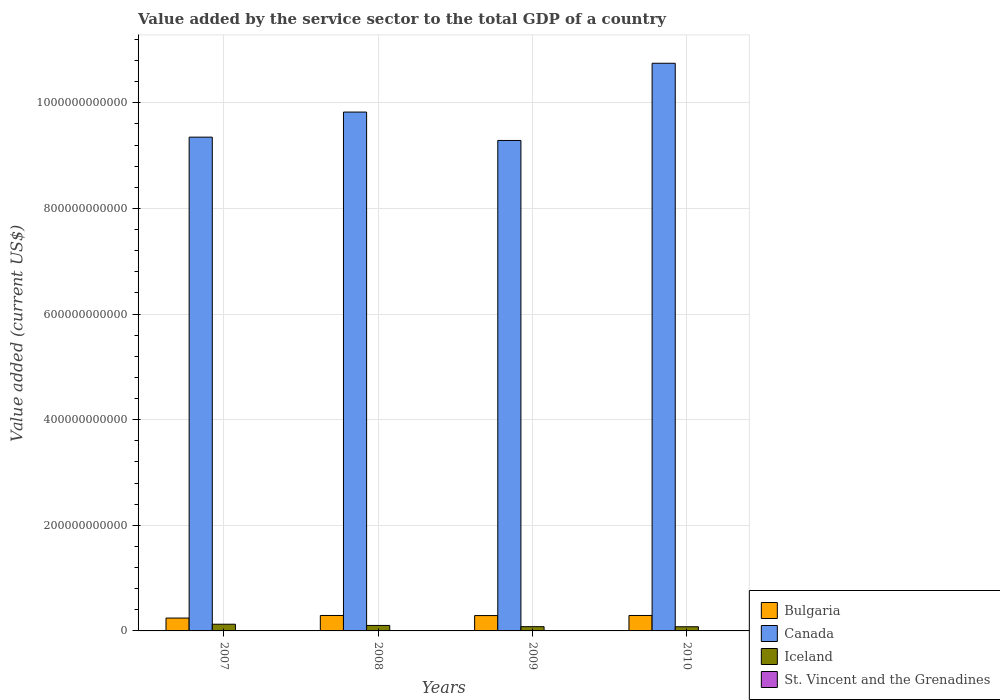How many groups of bars are there?
Offer a terse response. 4. How many bars are there on the 2nd tick from the left?
Ensure brevity in your answer.  4. In how many cases, is the number of bars for a given year not equal to the number of legend labels?
Your response must be concise. 0. What is the value added by the service sector to the total GDP in Canada in 2008?
Your response must be concise. 9.82e+11. Across all years, what is the maximum value added by the service sector to the total GDP in Canada?
Provide a short and direct response. 1.07e+12. Across all years, what is the minimum value added by the service sector to the total GDP in Iceland?
Ensure brevity in your answer.  7.87e+09. In which year was the value added by the service sector to the total GDP in Bulgaria maximum?
Ensure brevity in your answer.  2008. In which year was the value added by the service sector to the total GDP in St. Vincent and the Grenadines minimum?
Provide a succinct answer. 2009. What is the total value added by the service sector to the total GDP in Iceland in the graph?
Provide a succinct answer. 3.89e+1. What is the difference between the value added by the service sector to the total GDP in St. Vincent and the Grenadines in 2009 and that in 2010?
Your answer should be very brief. -6.89e+06. What is the difference between the value added by the service sector to the total GDP in St. Vincent and the Grenadines in 2010 and the value added by the service sector to the total GDP in Iceland in 2009?
Offer a terse response. -7.60e+09. What is the average value added by the service sector to the total GDP in St. Vincent and the Grenadines per year?
Provide a short and direct response. 4.24e+08. In the year 2009, what is the difference between the value added by the service sector to the total GDP in Bulgaria and value added by the service sector to the total GDP in Canada?
Provide a succinct answer. -9.00e+11. In how many years, is the value added by the service sector to the total GDP in Bulgaria greater than 400000000000 US$?
Ensure brevity in your answer.  0. What is the ratio of the value added by the service sector to the total GDP in Iceland in 2007 to that in 2008?
Your answer should be compact. 1.22. What is the difference between the highest and the second highest value added by the service sector to the total GDP in Bulgaria?
Your answer should be very brief. 1.87e+06. What is the difference between the highest and the lowest value added by the service sector to the total GDP in St. Vincent and the Grenadines?
Ensure brevity in your answer.  1.52e+07. Are all the bars in the graph horizontal?
Your answer should be compact. No. How many years are there in the graph?
Give a very brief answer. 4. What is the difference between two consecutive major ticks on the Y-axis?
Your answer should be compact. 2.00e+11. Are the values on the major ticks of Y-axis written in scientific E-notation?
Your answer should be compact. No. Where does the legend appear in the graph?
Ensure brevity in your answer.  Bottom right. How are the legend labels stacked?
Offer a terse response. Vertical. What is the title of the graph?
Your response must be concise. Value added by the service sector to the total GDP of a country. What is the label or title of the X-axis?
Your answer should be very brief. Years. What is the label or title of the Y-axis?
Provide a short and direct response. Value added (current US$). What is the Value added (current US$) in Bulgaria in 2007?
Keep it short and to the point. 2.44e+1. What is the Value added (current US$) in Canada in 2007?
Provide a short and direct response. 9.35e+11. What is the Value added (current US$) of Iceland in 2007?
Provide a short and direct response. 1.27e+1. What is the Value added (current US$) in St. Vincent and the Grenadines in 2007?
Provide a short and direct response. 4.25e+08. What is the Value added (current US$) of Bulgaria in 2008?
Your answer should be compact. 2.93e+1. What is the Value added (current US$) of Canada in 2008?
Your answer should be very brief. 9.82e+11. What is the Value added (current US$) of Iceland in 2008?
Offer a very short reply. 1.04e+1. What is the Value added (current US$) of St. Vincent and the Grenadines in 2008?
Provide a succinct answer. 4.31e+08. What is the Value added (current US$) in Bulgaria in 2009?
Provide a succinct answer. 2.91e+1. What is the Value added (current US$) in Canada in 2009?
Provide a short and direct response. 9.29e+11. What is the Value added (current US$) in Iceland in 2009?
Give a very brief answer. 8.03e+09. What is the Value added (current US$) of St. Vincent and the Grenadines in 2009?
Offer a terse response. 4.16e+08. What is the Value added (current US$) in Bulgaria in 2010?
Make the answer very short. 2.93e+1. What is the Value added (current US$) in Canada in 2010?
Keep it short and to the point. 1.07e+12. What is the Value added (current US$) of Iceland in 2010?
Make the answer very short. 7.87e+09. What is the Value added (current US$) in St. Vincent and the Grenadines in 2010?
Ensure brevity in your answer.  4.23e+08. Across all years, what is the maximum Value added (current US$) in Bulgaria?
Your answer should be very brief. 2.93e+1. Across all years, what is the maximum Value added (current US$) of Canada?
Keep it short and to the point. 1.07e+12. Across all years, what is the maximum Value added (current US$) of Iceland?
Make the answer very short. 1.27e+1. Across all years, what is the maximum Value added (current US$) of St. Vincent and the Grenadines?
Your answer should be very brief. 4.31e+08. Across all years, what is the minimum Value added (current US$) of Bulgaria?
Offer a terse response. 2.44e+1. Across all years, what is the minimum Value added (current US$) of Canada?
Your answer should be very brief. 9.29e+11. Across all years, what is the minimum Value added (current US$) of Iceland?
Provide a succinct answer. 7.87e+09. Across all years, what is the minimum Value added (current US$) in St. Vincent and the Grenadines?
Your answer should be compact. 4.16e+08. What is the total Value added (current US$) of Bulgaria in the graph?
Ensure brevity in your answer.  1.12e+11. What is the total Value added (current US$) in Canada in the graph?
Your response must be concise. 3.92e+12. What is the total Value added (current US$) of Iceland in the graph?
Give a very brief answer. 3.89e+1. What is the total Value added (current US$) in St. Vincent and the Grenadines in the graph?
Your answer should be compact. 1.70e+09. What is the difference between the Value added (current US$) of Bulgaria in 2007 and that in 2008?
Your response must be concise. -4.90e+09. What is the difference between the Value added (current US$) in Canada in 2007 and that in 2008?
Provide a short and direct response. -4.75e+1. What is the difference between the Value added (current US$) of Iceland in 2007 and that in 2008?
Offer a very short reply. 2.29e+09. What is the difference between the Value added (current US$) in St. Vincent and the Grenadines in 2007 and that in 2008?
Provide a short and direct response. -5.72e+06. What is the difference between the Value added (current US$) of Bulgaria in 2007 and that in 2009?
Provide a short and direct response. -4.69e+09. What is the difference between the Value added (current US$) of Canada in 2007 and that in 2009?
Your response must be concise. 6.28e+09. What is the difference between the Value added (current US$) of Iceland in 2007 and that in 2009?
Offer a very short reply. 4.64e+09. What is the difference between the Value added (current US$) in St. Vincent and the Grenadines in 2007 and that in 2009?
Your answer should be compact. 9.51e+06. What is the difference between the Value added (current US$) in Bulgaria in 2007 and that in 2010?
Offer a very short reply. -4.89e+09. What is the difference between the Value added (current US$) in Canada in 2007 and that in 2010?
Make the answer very short. -1.40e+11. What is the difference between the Value added (current US$) in Iceland in 2007 and that in 2010?
Keep it short and to the point. 4.79e+09. What is the difference between the Value added (current US$) in St. Vincent and the Grenadines in 2007 and that in 2010?
Offer a terse response. 2.62e+06. What is the difference between the Value added (current US$) of Bulgaria in 2008 and that in 2009?
Your answer should be very brief. 2.04e+08. What is the difference between the Value added (current US$) of Canada in 2008 and that in 2009?
Provide a succinct answer. 5.38e+1. What is the difference between the Value added (current US$) of Iceland in 2008 and that in 2009?
Give a very brief answer. 2.34e+09. What is the difference between the Value added (current US$) in St. Vincent and the Grenadines in 2008 and that in 2009?
Offer a terse response. 1.52e+07. What is the difference between the Value added (current US$) in Bulgaria in 2008 and that in 2010?
Offer a terse response. 1.87e+06. What is the difference between the Value added (current US$) in Canada in 2008 and that in 2010?
Your answer should be very brief. -9.24e+1. What is the difference between the Value added (current US$) of Iceland in 2008 and that in 2010?
Ensure brevity in your answer.  2.50e+09. What is the difference between the Value added (current US$) in St. Vincent and the Grenadines in 2008 and that in 2010?
Offer a terse response. 8.34e+06. What is the difference between the Value added (current US$) in Bulgaria in 2009 and that in 2010?
Offer a terse response. -2.02e+08. What is the difference between the Value added (current US$) in Canada in 2009 and that in 2010?
Keep it short and to the point. -1.46e+11. What is the difference between the Value added (current US$) in Iceland in 2009 and that in 2010?
Your response must be concise. 1.55e+08. What is the difference between the Value added (current US$) of St. Vincent and the Grenadines in 2009 and that in 2010?
Provide a short and direct response. -6.89e+06. What is the difference between the Value added (current US$) in Bulgaria in 2007 and the Value added (current US$) in Canada in 2008?
Provide a succinct answer. -9.58e+11. What is the difference between the Value added (current US$) of Bulgaria in 2007 and the Value added (current US$) of Iceland in 2008?
Ensure brevity in your answer.  1.40e+1. What is the difference between the Value added (current US$) of Bulgaria in 2007 and the Value added (current US$) of St. Vincent and the Grenadines in 2008?
Provide a short and direct response. 2.39e+1. What is the difference between the Value added (current US$) in Canada in 2007 and the Value added (current US$) in Iceland in 2008?
Provide a short and direct response. 9.25e+11. What is the difference between the Value added (current US$) in Canada in 2007 and the Value added (current US$) in St. Vincent and the Grenadines in 2008?
Your answer should be very brief. 9.34e+11. What is the difference between the Value added (current US$) in Iceland in 2007 and the Value added (current US$) in St. Vincent and the Grenadines in 2008?
Your answer should be very brief. 1.22e+1. What is the difference between the Value added (current US$) in Bulgaria in 2007 and the Value added (current US$) in Canada in 2009?
Give a very brief answer. -9.04e+11. What is the difference between the Value added (current US$) in Bulgaria in 2007 and the Value added (current US$) in Iceland in 2009?
Make the answer very short. 1.63e+1. What is the difference between the Value added (current US$) in Bulgaria in 2007 and the Value added (current US$) in St. Vincent and the Grenadines in 2009?
Your answer should be very brief. 2.39e+1. What is the difference between the Value added (current US$) in Canada in 2007 and the Value added (current US$) in Iceland in 2009?
Keep it short and to the point. 9.27e+11. What is the difference between the Value added (current US$) of Canada in 2007 and the Value added (current US$) of St. Vincent and the Grenadines in 2009?
Keep it short and to the point. 9.35e+11. What is the difference between the Value added (current US$) of Iceland in 2007 and the Value added (current US$) of St. Vincent and the Grenadines in 2009?
Your answer should be very brief. 1.23e+1. What is the difference between the Value added (current US$) of Bulgaria in 2007 and the Value added (current US$) of Canada in 2010?
Offer a very short reply. -1.05e+12. What is the difference between the Value added (current US$) in Bulgaria in 2007 and the Value added (current US$) in Iceland in 2010?
Provide a succinct answer. 1.65e+1. What is the difference between the Value added (current US$) in Bulgaria in 2007 and the Value added (current US$) in St. Vincent and the Grenadines in 2010?
Your response must be concise. 2.39e+1. What is the difference between the Value added (current US$) in Canada in 2007 and the Value added (current US$) in Iceland in 2010?
Provide a short and direct response. 9.27e+11. What is the difference between the Value added (current US$) of Canada in 2007 and the Value added (current US$) of St. Vincent and the Grenadines in 2010?
Your response must be concise. 9.35e+11. What is the difference between the Value added (current US$) in Iceland in 2007 and the Value added (current US$) in St. Vincent and the Grenadines in 2010?
Give a very brief answer. 1.22e+1. What is the difference between the Value added (current US$) of Bulgaria in 2008 and the Value added (current US$) of Canada in 2009?
Ensure brevity in your answer.  -8.99e+11. What is the difference between the Value added (current US$) in Bulgaria in 2008 and the Value added (current US$) in Iceland in 2009?
Offer a terse response. 2.12e+1. What is the difference between the Value added (current US$) in Bulgaria in 2008 and the Value added (current US$) in St. Vincent and the Grenadines in 2009?
Offer a terse response. 2.88e+1. What is the difference between the Value added (current US$) of Canada in 2008 and the Value added (current US$) of Iceland in 2009?
Give a very brief answer. 9.74e+11. What is the difference between the Value added (current US$) of Canada in 2008 and the Value added (current US$) of St. Vincent and the Grenadines in 2009?
Provide a succinct answer. 9.82e+11. What is the difference between the Value added (current US$) in Iceland in 2008 and the Value added (current US$) in St. Vincent and the Grenadines in 2009?
Provide a succinct answer. 9.96e+09. What is the difference between the Value added (current US$) in Bulgaria in 2008 and the Value added (current US$) in Canada in 2010?
Your response must be concise. -1.05e+12. What is the difference between the Value added (current US$) in Bulgaria in 2008 and the Value added (current US$) in Iceland in 2010?
Ensure brevity in your answer.  2.14e+1. What is the difference between the Value added (current US$) in Bulgaria in 2008 and the Value added (current US$) in St. Vincent and the Grenadines in 2010?
Ensure brevity in your answer.  2.88e+1. What is the difference between the Value added (current US$) in Canada in 2008 and the Value added (current US$) in Iceland in 2010?
Make the answer very short. 9.75e+11. What is the difference between the Value added (current US$) in Canada in 2008 and the Value added (current US$) in St. Vincent and the Grenadines in 2010?
Keep it short and to the point. 9.82e+11. What is the difference between the Value added (current US$) in Iceland in 2008 and the Value added (current US$) in St. Vincent and the Grenadines in 2010?
Ensure brevity in your answer.  9.95e+09. What is the difference between the Value added (current US$) of Bulgaria in 2009 and the Value added (current US$) of Canada in 2010?
Ensure brevity in your answer.  -1.05e+12. What is the difference between the Value added (current US$) in Bulgaria in 2009 and the Value added (current US$) in Iceland in 2010?
Your answer should be very brief. 2.12e+1. What is the difference between the Value added (current US$) in Bulgaria in 2009 and the Value added (current US$) in St. Vincent and the Grenadines in 2010?
Your answer should be very brief. 2.86e+1. What is the difference between the Value added (current US$) of Canada in 2009 and the Value added (current US$) of Iceland in 2010?
Make the answer very short. 9.21e+11. What is the difference between the Value added (current US$) in Canada in 2009 and the Value added (current US$) in St. Vincent and the Grenadines in 2010?
Make the answer very short. 9.28e+11. What is the difference between the Value added (current US$) of Iceland in 2009 and the Value added (current US$) of St. Vincent and the Grenadines in 2010?
Provide a short and direct response. 7.60e+09. What is the average Value added (current US$) of Bulgaria per year?
Provide a short and direct response. 2.80e+1. What is the average Value added (current US$) in Canada per year?
Your response must be concise. 9.80e+11. What is the average Value added (current US$) of Iceland per year?
Keep it short and to the point. 9.73e+09. What is the average Value added (current US$) in St. Vincent and the Grenadines per year?
Your answer should be very brief. 4.24e+08. In the year 2007, what is the difference between the Value added (current US$) in Bulgaria and Value added (current US$) in Canada?
Provide a succinct answer. -9.11e+11. In the year 2007, what is the difference between the Value added (current US$) of Bulgaria and Value added (current US$) of Iceland?
Provide a succinct answer. 1.17e+1. In the year 2007, what is the difference between the Value added (current US$) of Bulgaria and Value added (current US$) of St. Vincent and the Grenadines?
Your answer should be very brief. 2.39e+1. In the year 2007, what is the difference between the Value added (current US$) in Canada and Value added (current US$) in Iceland?
Your answer should be very brief. 9.22e+11. In the year 2007, what is the difference between the Value added (current US$) in Canada and Value added (current US$) in St. Vincent and the Grenadines?
Your answer should be compact. 9.35e+11. In the year 2007, what is the difference between the Value added (current US$) in Iceland and Value added (current US$) in St. Vincent and the Grenadines?
Offer a terse response. 1.22e+1. In the year 2008, what is the difference between the Value added (current US$) in Bulgaria and Value added (current US$) in Canada?
Provide a short and direct response. -9.53e+11. In the year 2008, what is the difference between the Value added (current US$) of Bulgaria and Value added (current US$) of Iceland?
Provide a succinct answer. 1.89e+1. In the year 2008, what is the difference between the Value added (current US$) of Bulgaria and Value added (current US$) of St. Vincent and the Grenadines?
Keep it short and to the point. 2.88e+1. In the year 2008, what is the difference between the Value added (current US$) in Canada and Value added (current US$) in Iceland?
Your response must be concise. 9.72e+11. In the year 2008, what is the difference between the Value added (current US$) of Canada and Value added (current US$) of St. Vincent and the Grenadines?
Offer a terse response. 9.82e+11. In the year 2008, what is the difference between the Value added (current US$) in Iceland and Value added (current US$) in St. Vincent and the Grenadines?
Provide a short and direct response. 9.94e+09. In the year 2009, what is the difference between the Value added (current US$) of Bulgaria and Value added (current US$) of Canada?
Offer a terse response. -9.00e+11. In the year 2009, what is the difference between the Value added (current US$) in Bulgaria and Value added (current US$) in Iceland?
Ensure brevity in your answer.  2.10e+1. In the year 2009, what is the difference between the Value added (current US$) in Bulgaria and Value added (current US$) in St. Vincent and the Grenadines?
Provide a short and direct response. 2.86e+1. In the year 2009, what is the difference between the Value added (current US$) in Canada and Value added (current US$) in Iceland?
Ensure brevity in your answer.  9.21e+11. In the year 2009, what is the difference between the Value added (current US$) of Canada and Value added (current US$) of St. Vincent and the Grenadines?
Provide a short and direct response. 9.28e+11. In the year 2009, what is the difference between the Value added (current US$) in Iceland and Value added (current US$) in St. Vincent and the Grenadines?
Ensure brevity in your answer.  7.61e+09. In the year 2010, what is the difference between the Value added (current US$) in Bulgaria and Value added (current US$) in Canada?
Give a very brief answer. -1.05e+12. In the year 2010, what is the difference between the Value added (current US$) of Bulgaria and Value added (current US$) of Iceland?
Offer a terse response. 2.14e+1. In the year 2010, what is the difference between the Value added (current US$) in Bulgaria and Value added (current US$) in St. Vincent and the Grenadines?
Keep it short and to the point. 2.88e+1. In the year 2010, what is the difference between the Value added (current US$) in Canada and Value added (current US$) in Iceland?
Ensure brevity in your answer.  1.07e+12. In the year 2010, what is the difference between the Value added (current US$) in Canada and Value added (current US$) in St. Vincent and the Grenadines?
Make the answer very short. 1.07e+12. In the year 2010, what is the difference between the Value added (current US$) of Iceland and Value added (current US$) of St. Vincent and the Grenadines?
Offer a very short reply. 7.45e+09. What is the ratio of the Value added (current US$) of Bulgaria in 2007 to that in 2008?
Your answer should be compact. 0.83. What is the ratio of the Value added (current US$) of Canada in 2007 to that in 2008?
Give a very brief answer. 0.95. What is the ratio of the Value added (current US$) in Iceland in 2007 to that in 2008?
Provide a short and direct response. 1.22. What is the ratio of the Value added (current US$) in St. Vincent and the Grenadines in 2007 to that in 2008?
Your response must be concise. 0.99. What is the ratio of the Value added (current US$) in Bulgaria in 2007 to that in 2009?
Provide a succinct answer. 0.84. What is the ratio of the Value added (current US$) in Canada in 2007 to that in 2009?
Your answer should be compact. 1.01. What is the ratio of the Value added (current US$) in Iceland in 2007 to that in 2009?
Offer a terse response. 1.58. What is the ratio of the Value added (current US$) in St. Vincent and the Grenadines in 2007 to that in 2009?
Your answer should be very brief. 1.02. What is the ratio of the Value added (current US$) of Bulgaria in 2007 to that in 2010?
Your response must be concise. 0.83. What is the ratio of the Value added (current US$) of Canada in 2007 to that in 2010?
Your answer should be compact. 0.87. What is the ratio of the Value added (current US$) of Iceland in 2007 to that in 2010?
Make the answer very short. 1.61. What is the ratio of the Value added (current US$) in Canada in 2008 to that in 2009?
Offer a very short reply. 1.06. What is the ratio of the Value added (current US$) of Iceland in 2008 to that in 2009?
Your response must be concise. 1.29. What is the ratio of the Value added (current US$) of St. Vincent and the Grenadines in 2008 to that in 2009?
Your answer should be compact. 1.04. What is the ratio of the Value added (current US$) in Canada in 2008 to that in 2010?
Your response must be concise. 0.91. What is the ratio of the Value added (current US$) of Iceland in 2008 to that in 2010?
Provide a succinct answer. 1.32. What is the ratio of the Value added (current US$) of St. Vincent and the Grenadines in 2008 to that in 2010?
Your answer should be compact. 1.02. What is the ratio of the Value added (current US$) of Canada in 2009 to that in 2010?
Offer a very short reply. 0.86. What is the ratio of the Value added (current US$) of Iceland in 2009 to that in 2010?
Make the answer very short. 1.02. What is the ratio of the Value added (current US$) of St. Vincent and the Grenadines in 2009 to that in 2010?
Offer a very short reply. 0.98. What is the difference between the highest and the second highest Value added (current US$) in Bulgaria?
Ensure brevity in your answer.  1.87e+06. What is the difference between the highest and the second highest Value added (current US$) in Canada?
Your answer should be compact. 9.24e+1. What is the difference between the highest and the second highest Value added (current US$) in Iceland?
Offer a terse response. 2.29e+09. What is the difference between the highest and the second highest Value added (current US$) of St. Vincent and the Grenadines?
Your answer should be very brief. 5.72e+06. What is the difference between the highest and the lowest Value added (current US$) of Bulgaria?
Provide a succinct answer. 4.90e+09. What is the difference between the highest and the lowest Value added (current US$) of Canada?
Ensure brevity in your answer.  1.46e+11. What is the difference between the highest and the lowest Value added (current US$) in Iceland?
Ensure brevity in your answer.  4.79e+09. What is the difference between the highest and the lowest Value added (current US$) of St. Vincent and the Grenadines?
Your answer should be very brief. 1.52e+07. 